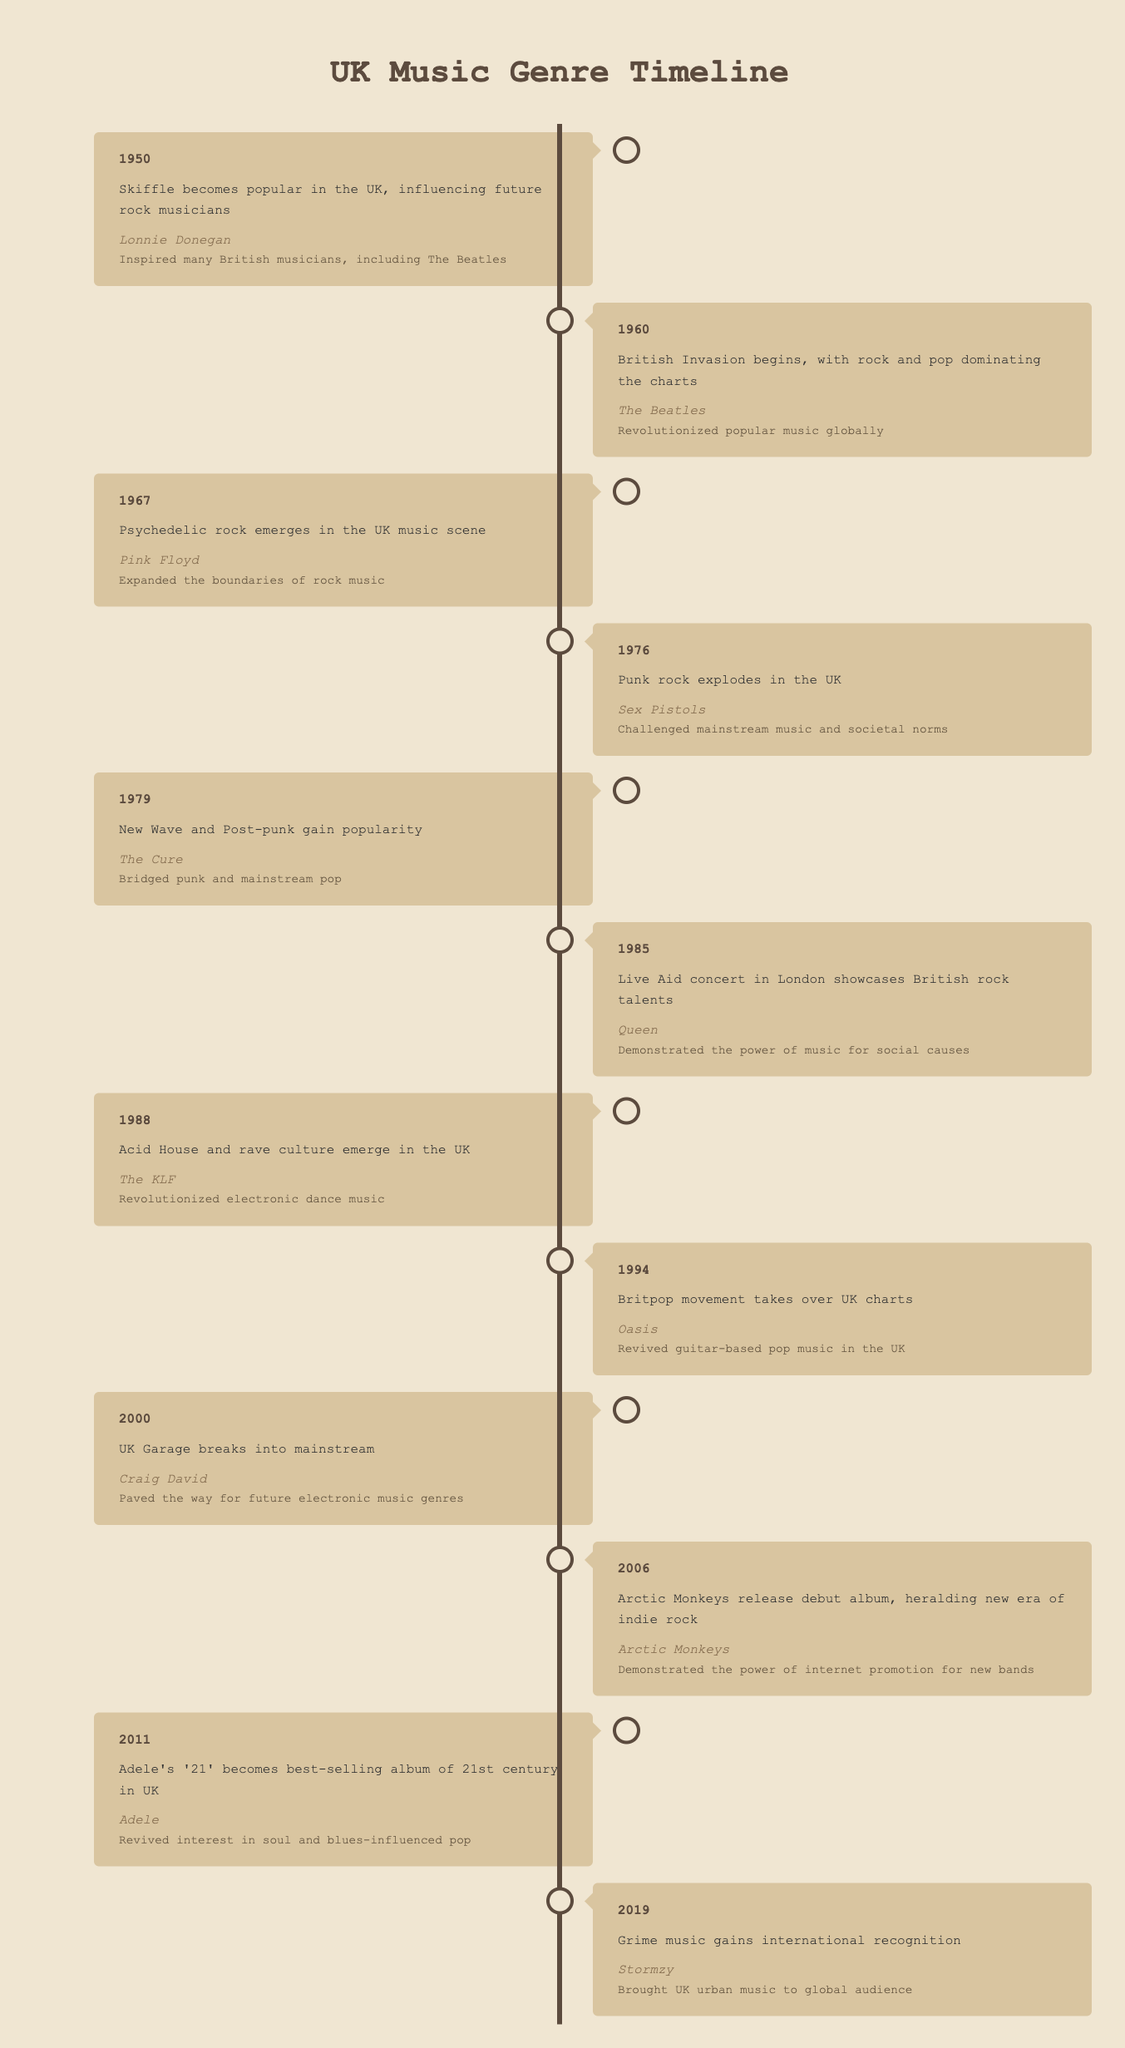What year did Punk rock explode in the UK? The table indicates that Punk rock exploded in the UK in the year 1976. This can be identified directly from the event for that year.
Answer: 1976 Who was the artist that popularized Skiffle in the UK? According to the table, the artist associated with popularizing Skiffle in the UK in 1950 is Lonnie Donegan, as listed in the corresponding event of that year.
Answer: Lonnie Donegan What type of music emerged in the UK around 1988? Based on the table, Acid House and rave culture emerged in the UK music scene in 1988, as stated in the entry for that year.
Answer: Acid House and rave culture Which artist is credited with the revival of interest in soul and blues-influenced pop? The artist credited with this revival is Adele, specifically with her album '21' released in 2011, and this is mentioned in the relevant entry for that year.
Answer: Adele How many years were between the emergence of Britpop in 1994 and the gaining of international recognition of Grime music in 2019? To find the number of years between these two events, subtract 1994 from 2019, which gives us 2019 - 1994 = 25 years. This simple subtraction indicates the duration.
Answer: 25 years Did the Acid House and rave culture emerge after the Punk rock explosion? Yes, according to the table, Acid House and rave culture emerged in 1988, which is after Punk rock exploded in 1976, confirming the statement as true.
Answer: Yes Which music genre emerged first: Psychedelic rock or New Wave? The table shows that Psychedelic rock emerged in 1967 and New Wave gained popularity in 1979. Since 1967 is earlier than 1979, Psychedelic rock emerged first.
Answer: Psychedelic rock What impact did the Live Aid concert have on perceptions of music? The impact noted for the Live Aid concert in 1985 is that it demonstrated the power of music for social causes. This is a direct mention in the table for that specific event.
Answer: Demonstrated the power of music for social causes Which event marked the introduction of UK Garage into the mainstream? The table states that UK Garage broke into the mainstream in the year 2000, which directly answers the question based on the corresponding event.
Answer: UK Garage broke into the mainstream in 2000 How did the Arctic Monkeys influence the music scene upon their debut? According to the table, the release of Arctic Monkeys' debut album in 2006 heralded a new era of indie rock and demonstrated the power of internet promotion for new bands, highlighting their influence.
Answer: Demonstrated the power of internet promotion for new bands 